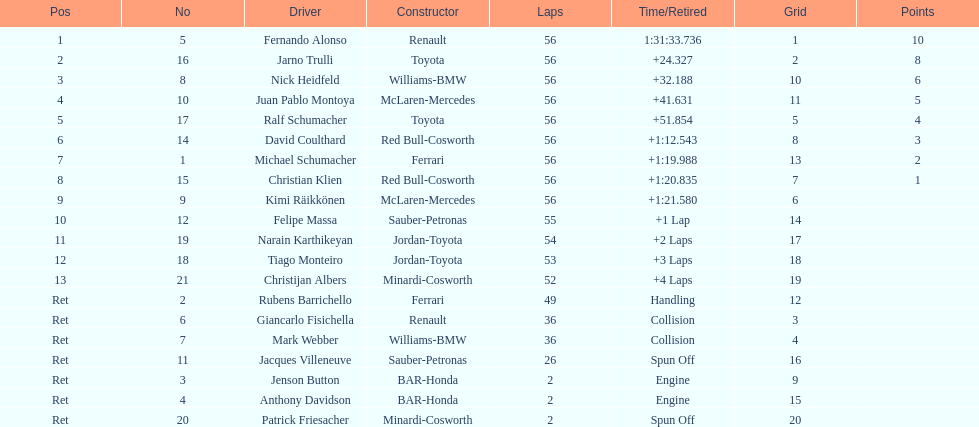Which driver secured the first position? Fernando Alonso. 